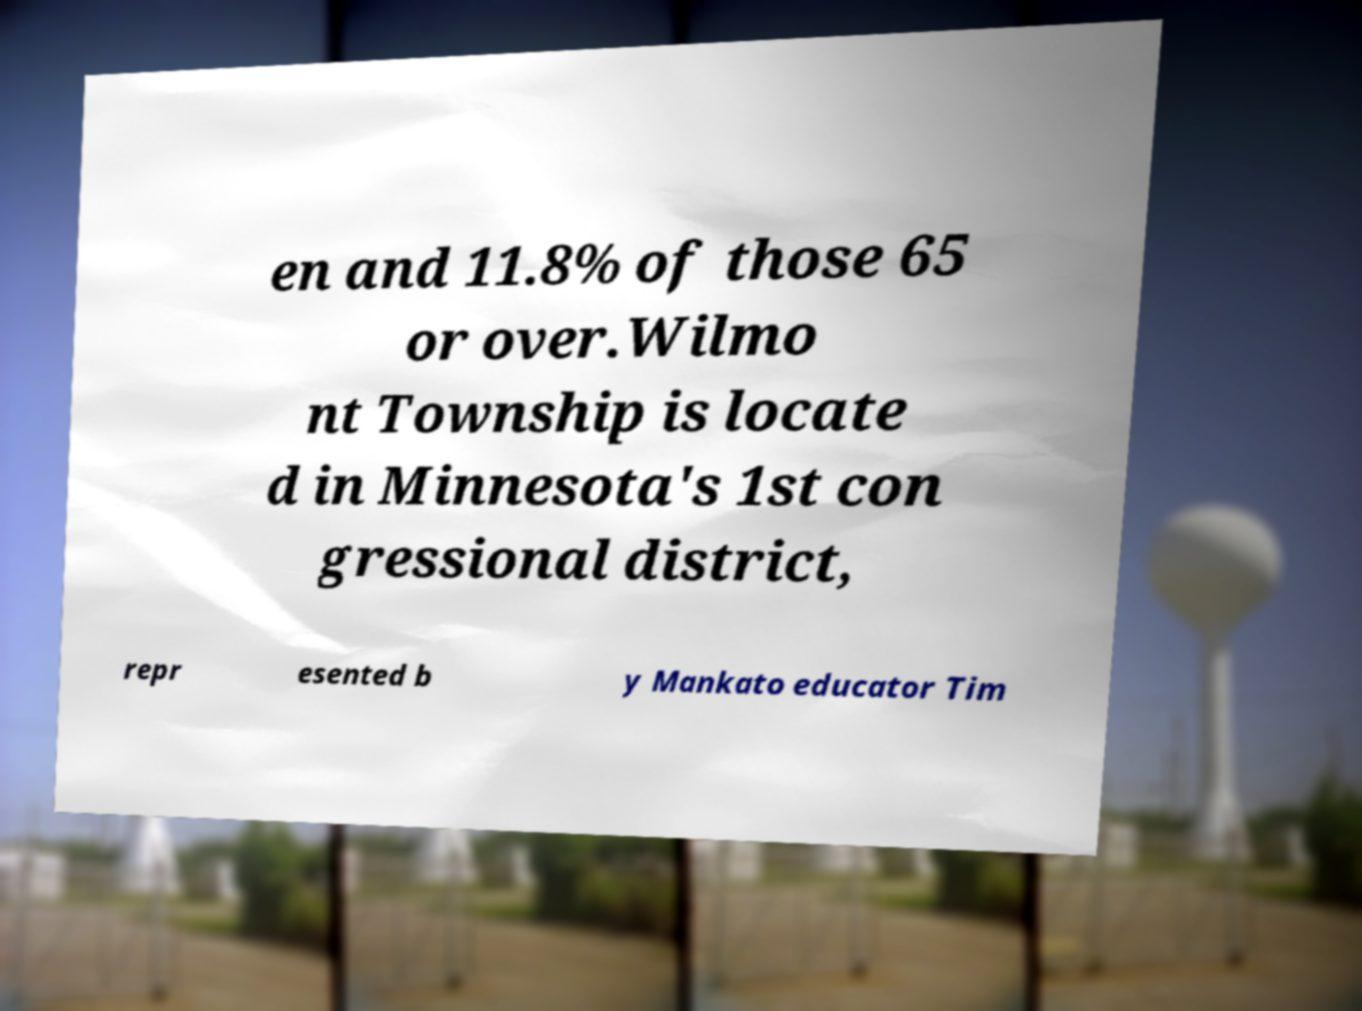Please identify and transcribe the text found in this image. en and 11.8% of those 65 or over.Wilmo nt Township is locate d in Minnesota's 1st con gressional district, repr esented b y Mankato educator Tim 